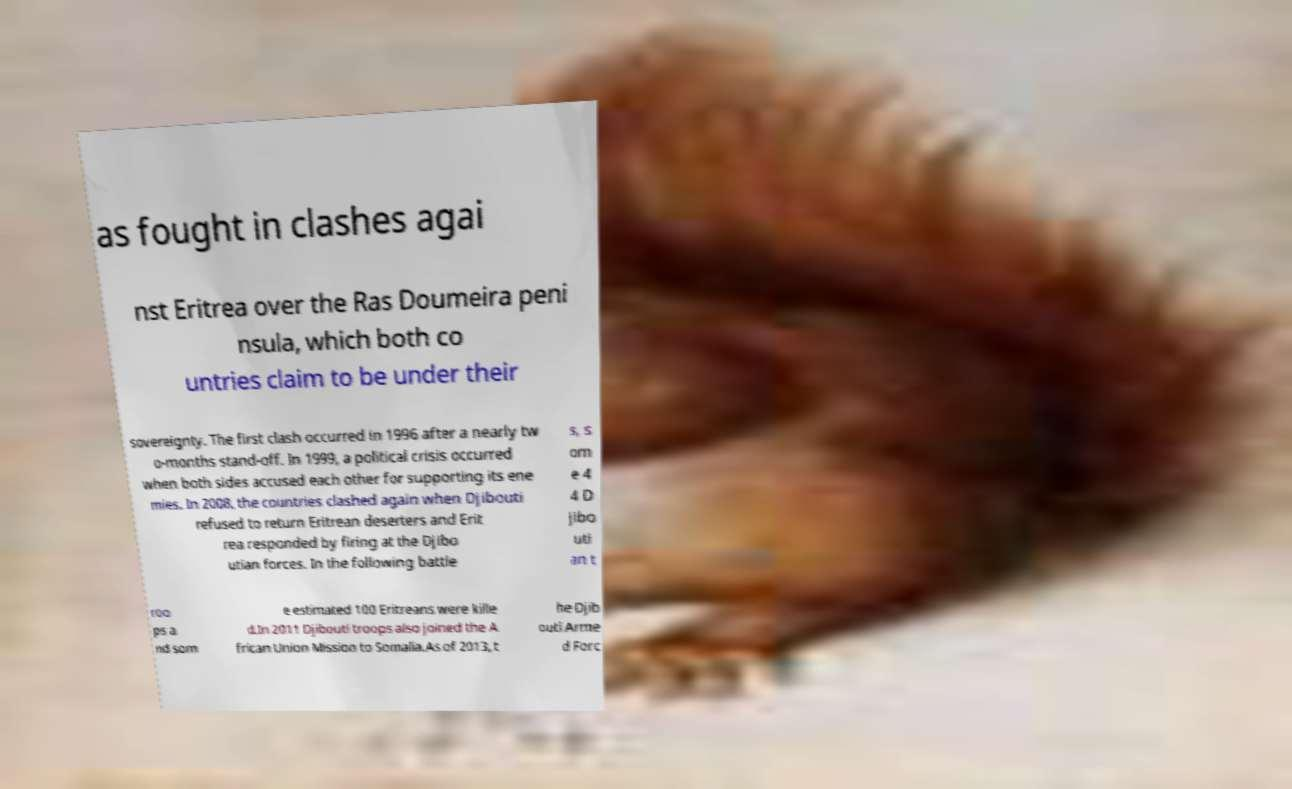Can you accurately transcribe the text from the provided image for me? as fought in clashes agai nst Eritrea over the Ras Doumeira peni nsula, which both co untries claim to be under their sovereignty. The first clash occurred in 1996 after a nearly tw o-months stand-off. In 1999, a political crisis occurred when both sides accused each other for supporting its ene mies. In 2008, the countries clashed again when Djibouti refused to return Eritrean deserters and Erit rea responded by firing at the Djibo utian forces. In the following battle s, s om e 4 4 D jibo uti an t roo ps a nd som e estimated 100 Eritreans were kille d.In 2011 Djibouti troops also joined the A frican Union Mission to Somalia.As of 2013, t he Djib outi Arme d Forc 